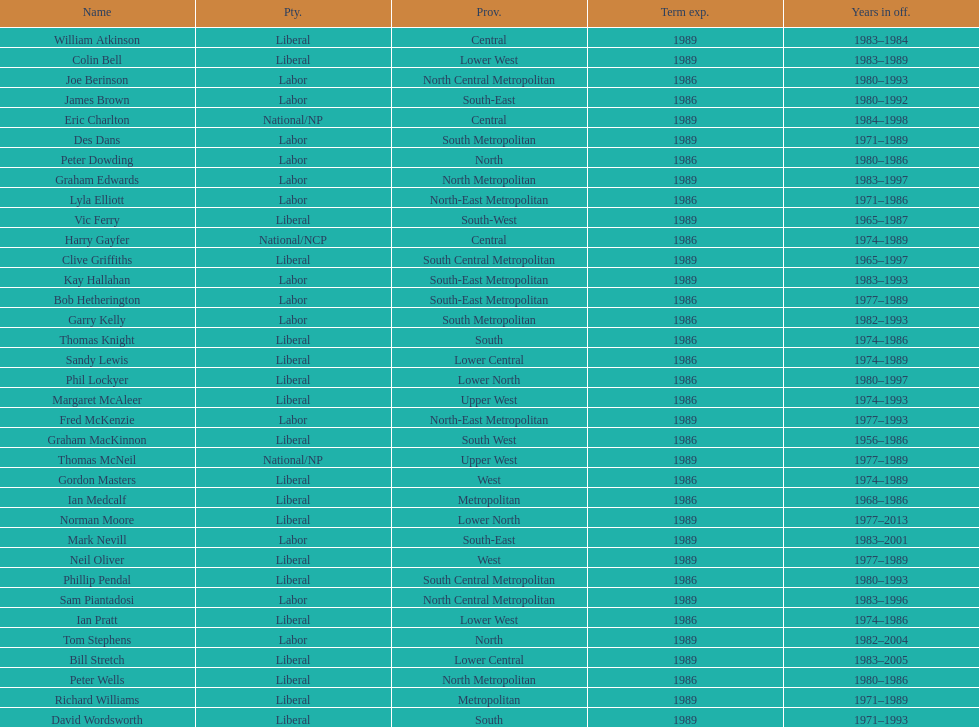Who has had the shortest term in office William Atkinson. 